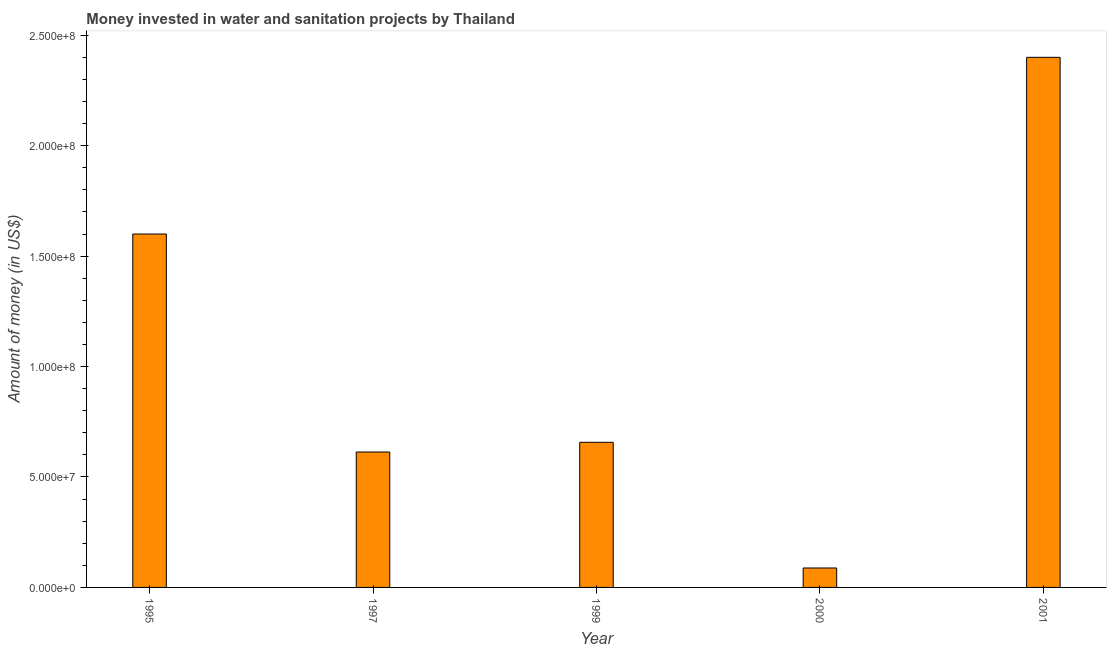Does the graph contain any zero values?
Your answer should be very brief. No. What is the title of the graph?
Ensure brevity in your answer.  Money invested in water and sanitation projects by Thailand. What is the label or title of the X-axis?
Your response must be concise. Year. What is the label or title of the Y-axis?
Provide a succinct answer. Amount of money (in US$). What is the investment in 1997?
Offer a terse response. 6.13e+07. Across all years, what is the maximum investment?
Offer a terse response. 2.40e+08. Across all years, what is the minimum investment?
Provide a succinct answer. 8.80e+06. In which year was the investment maximum?
Your answer should be very brief. 2001. What is the sum of the investment?
Your answer should be compact. 5.36e+08. What is the difference between the investment in 1995 and 2001?
Offer a terse response. -8.00e+07. What is the average investment per year?
Your answer should be compact. 1.07e+08. What is the median investment?
Keep it short and to the point. 6.57e+07. In how many years, is the investment greater than 100000000 US$?
Offer a terse response. 2. What is the ratio of the investment in 1997 to that in 2000?
Ensure brevity in your answer.  6.97. Is the investment in 1997 less than that in 2000?
Ensure brevity in your answer.  No. Is the difference between the investment in 1995 and 2001 greater than the difference between any two years?
Make the answer very short. No. What is the difference between the highest and the second highest investment?
Your answer should be compact. 8.00e+07. Is the sum of the investment in 1995 and 2001 greater than the maximum investment across all years?
Your response must be concise. Yes. What is the difference between the highest and the lowest investment?
Make the answer very short. 2.31e+08. Are all the bars in the graph horizontal?
Make the answer very short. No. What is the difference between two consecutive major ticks on the Y-axis?
Provide a succinct answer. 5.00e+07. What is the Amount of money (in US$) in 1995?
Offer a terse response. 1.60e+08. What is the Amount of money (in US$) in 1997?
Your answer should be compact. 6.13e+07. What is the Amount of money (in US$) of 1999?
Your response must be concise. 6.57e+07. What is the Amount of money (in US$) of 2000?
Offer a terse response. 8.80e+06. What is the Amount of money (in US$) in 2001?
Offer a terse response. 2.40e+08. What is the difference between the Amount of money (in US$) in 1995 and 1997?
Offer a very short reply. 9.87e+07. What is the difference between the Amount of money (in US$) in 1995 and 1999?
Provide a short and direct response. 9.43e+07. What is the difference between the Amount of money (in US$) in 1995 and 2000?
Offer a terse response. 1.51e+08. What is the difference between the Amount of money (in US$) in 1995 and 2001?
Your answer should be compact. -8.00e+07. What is the difference between the Amount of money (in US$) in 1997 and 1999?
Your answer should be very brief. -4.40e+06. What is the difference between the Amount of money (in US$) in 1997 and 2000?
Make the answer very short. 5.25e+07. What is the difference between the Amount of money (in US$) in 1997 and 2001?
Your answer should be very brief. -1.79e+08. What is the difference between the Amount of money (in US$) in 1999 and 2000?
Your answer should be very brief. 5.69e+07. What is the difference between the Amount of money (in US$) in 1999 and 2001?
Provide a succinct answer. -1.74e+08. What is the difference between the Amount of money (in US$) in 2000 and 2001?
Your answer should be compact. -2.31e+08. What is the ratio of the Amount of money (in US$) in 1995 to that in 1997?
Offer a terse response. 2.61. What is the ratio of the Amount of money (in US$) in 1995 to that in 1999?
Offer a very short reply. 2.44. What is the ratio of the Amount of money (in US$) in 1995 to that in 2000?
Offer a terse response. 18.18. What is the ratio of the Amount of money (in US$) in 1995 to that in 2001?
Offer a very short reply. 0.67. What is the ratio of the Amount of money (in US$) in 1997 to that in 1999?
Offer a terse response. 0.93. What is the ratio of the Amount of money (in US$) in 1997 to that in 2000?
Make the answer very short. 6.97. What is the ratio of the Amount of money (in US$) in 1997 to that in 2001?
Offer a very short reply. 0.26. What is the ratio of the Amount of money (in US$) in 1999 to that in 2000?
Ensure brevity in your answer.  7.47. What is the ratio of the Amount of money (in US$) in 1999 to that in 2001?
Offer a very short reply. 0.27. What is the ratio of the Amount of money (in US$) in 2000 to that in 2001?
Give a very brief answer. 0.04. 